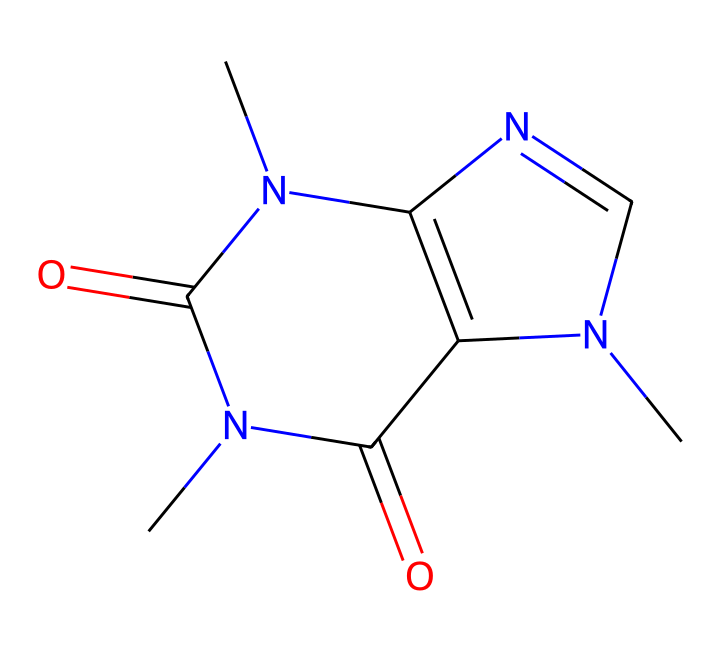What is the molecular formula of this compound? To determine the molecular formula, count the number of each type of atom represented in the SMILES notation. Scanning CN1C=NC2=C1C(=O)N(C(=O)N2C), we find: C (5), H (6), N (4), O (2). Therefore, the molecular formula is C5H6N4O2.
Answer: C5H6N4O2 How many nitrogen atoms are in the structure? By examining the SMILES string, we can identify the nitrogen atoms (N). In the provided structure, there are a total of 4 nitrogen atoms present.
Answer: 4 What type of compound is caffeine classified as? Caffeine is classified as an alkaloid due to its structure which includes nitrogen atoms contributing to its physiological effects as a stimulant, predominantly found in plants.
Answer: alkaloid How many rings are present in this structure? In the SMILES representation, we can see the numbers (1 and 2) indicating cyclic structures. C1 and C2 indicate the formation of two interconnected rings in the molecular arrangement.
Answer: 2 What functional groups are present in this compound? Analyzing the structure, we identify the functional groups: two carbonyl groups (C=O) implied by the presence of (=O). These carbonyls are part of the amide groups associated with nitrogen atoms in the structure.
Answer: two carbonyl groups What is the role of caffeine in boosting productivity? Caffeine acts as a central nervous system stimulant by blocking adenosine receptors, leading to increased alertness and reduced fatigue, which can enhance productivity during long retail shifts.
Answer: stimulant Does this compound have any chiral centers? The structure lacks any carbon atoms that are bonded to four different substituents, which are necessary to create chiral centers. Therefore, this compound is achiral.
Answer: achiral 